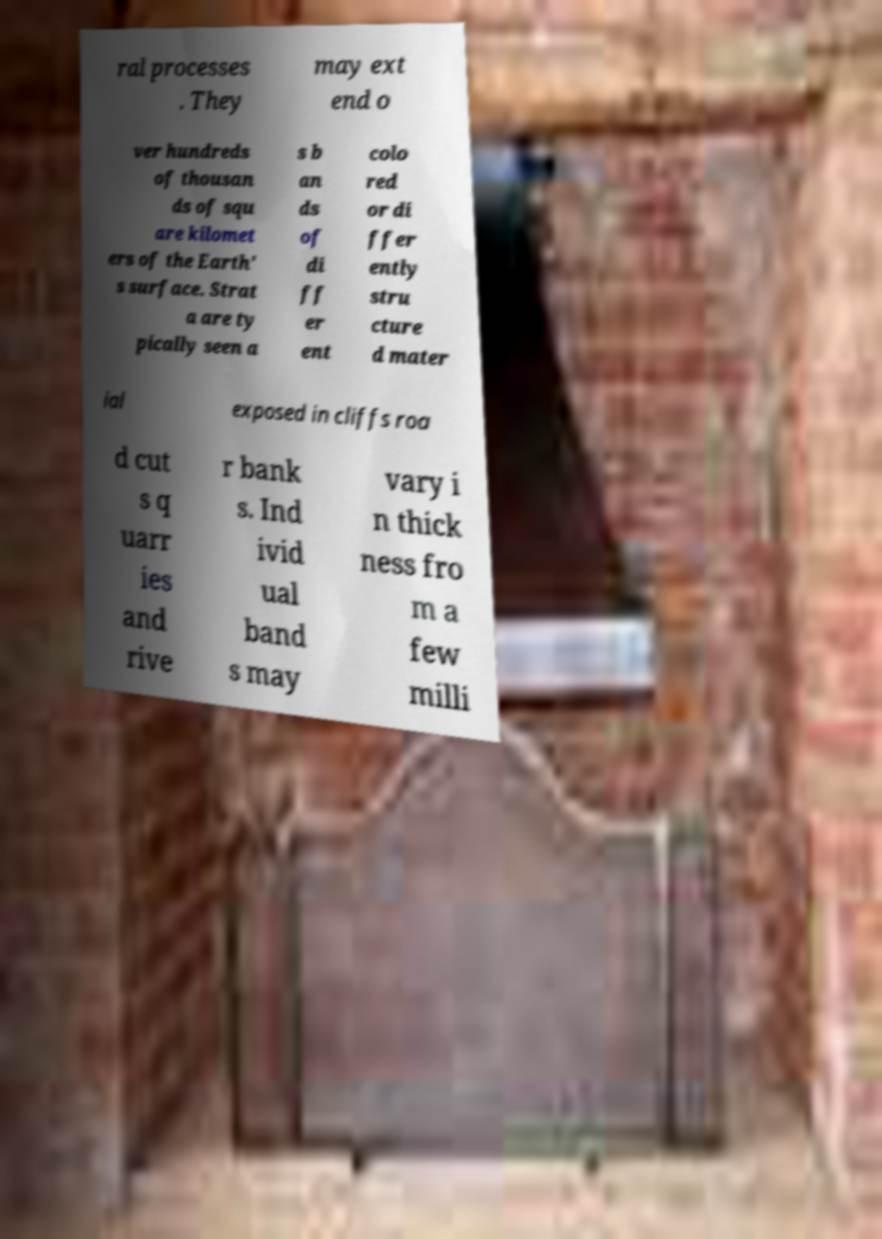For documentation purposes, I need the text within this image transcribed. Could you provide that? ral processes . They may ext end o ver hundreds of thousan ds of squ are kilomet ers of the Earth' s surface. Strat a are ty pically seen a s b an ds of di ff er ent colo red or di ffer ently stru cture d mater ial exposed in cliffs roa d cut s q uarr ies and rive r bank s. Ind ivid ual band s may vary i n thick ness fro m a few milli 